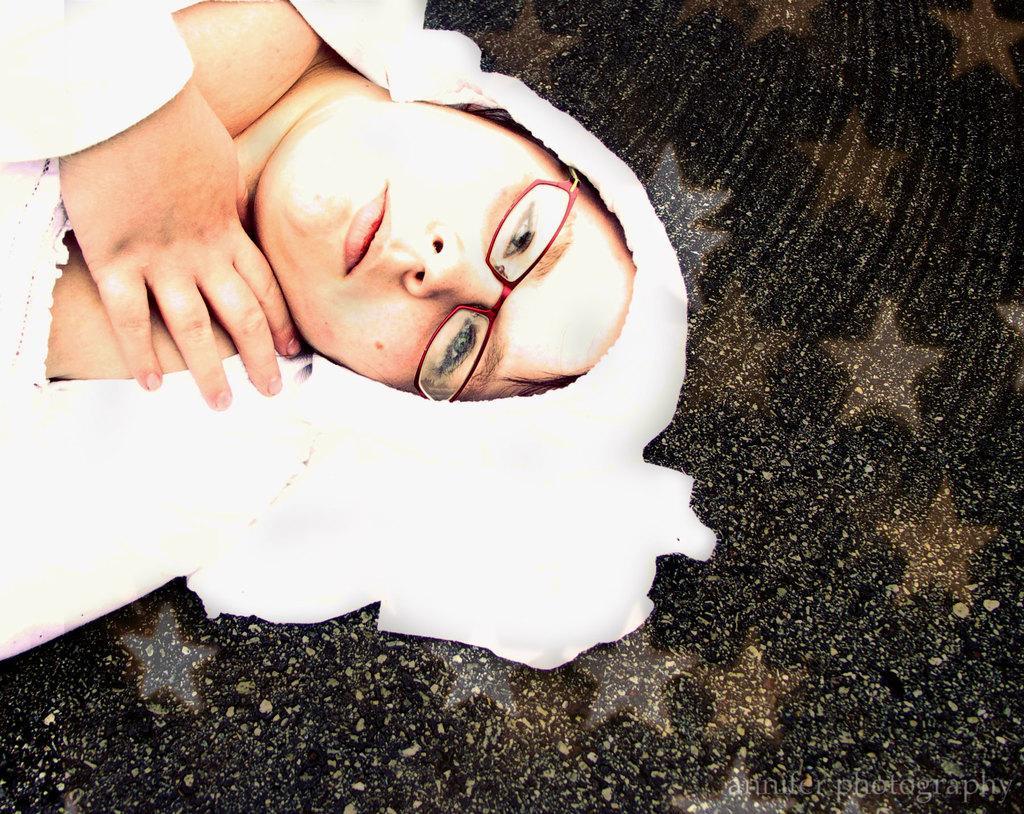Please provide a concise description of this image. In the picture I can see a woman is lying on a surface. The woman is wearing spectacles and white color clothes. 